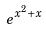<formula> <loc_0><loc_0><loc_500><loc_500>e ^ { x ^ { 2 } + x }</formula> 